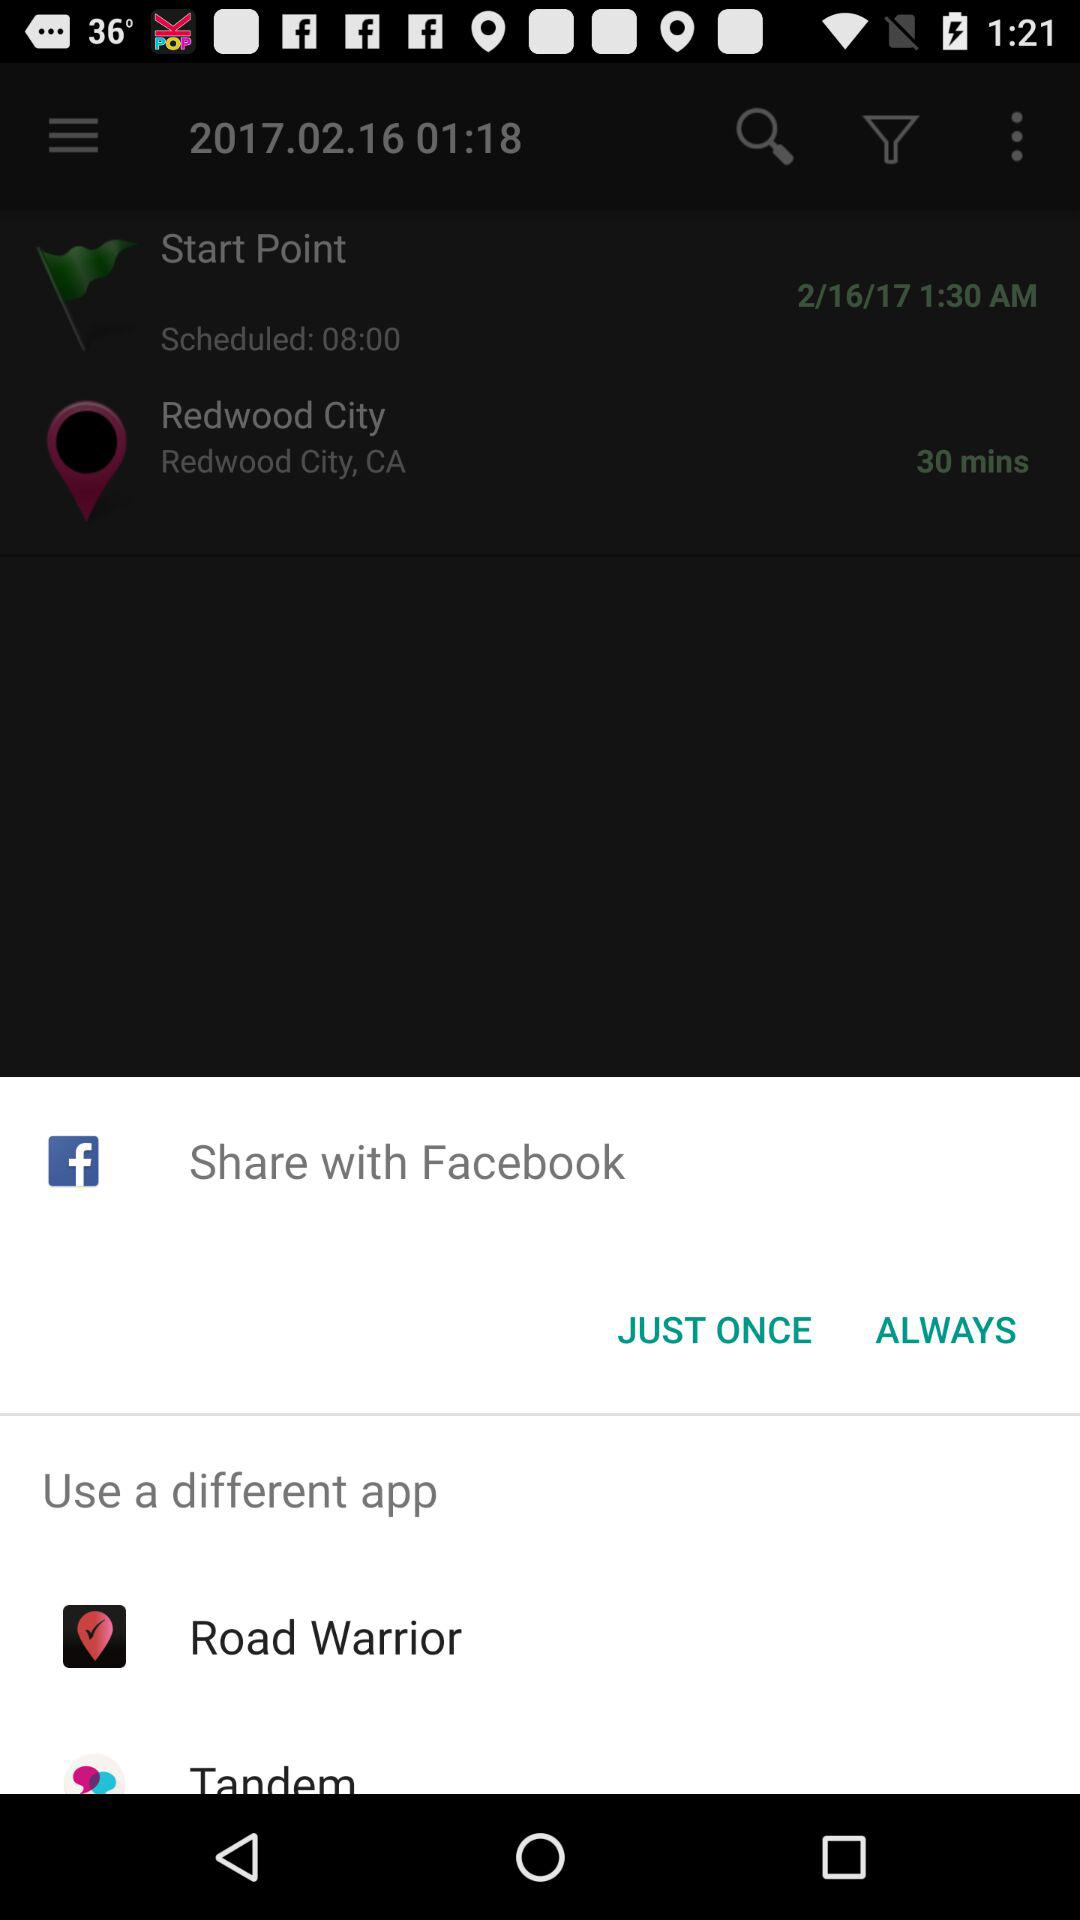What's the name of the different application that can be used? The names of the different applications that can be used are "Road Warrior" and "Tandem". 